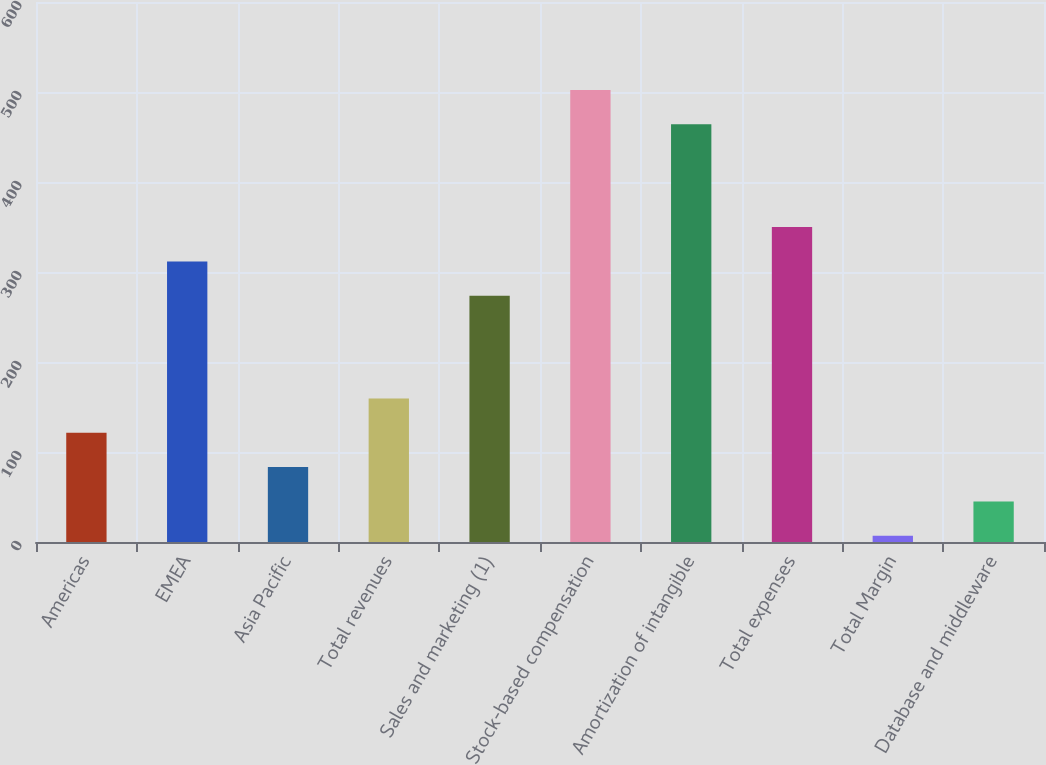Convert chart. <chart><loc_0><loc_0><loc_500><loc_500><bar_chart><fcel>Americas<fcel>EMEA<fcel>Asia Pacific<fcel>Total revenues<fcel>Sales and marketing (1)<fcel>Stock-based compensation<fcel>Amortization of intangible<fcel>Total expenses<fcel>Total Margin<fcel>Database and middleware<nl><fcel>121.3<fcel>311.8<fcel>83.2<fcel>159.4<fcel>273.7<fcel>502.3<fcel>464.2<fcel>349.9<fcel>7<fcel>45.1<nl></chart> 